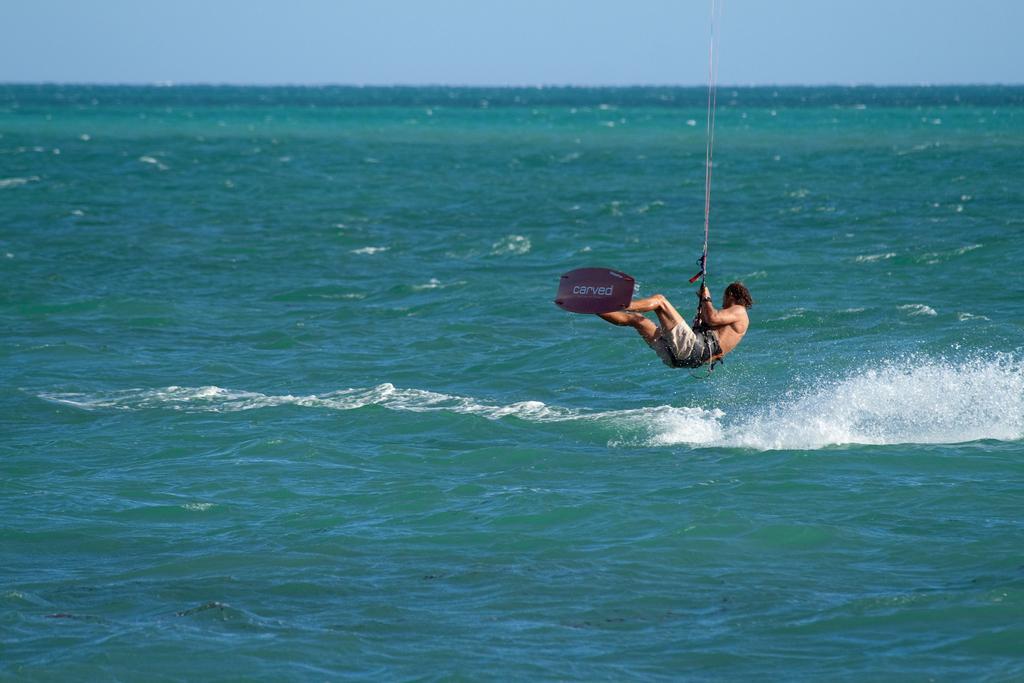Please provide a concise description of this image. In this image we can see a person wearing short doing surfing on the waves and the board is of pink color holding a rope which is tied to his waist and in the background of the image we can see water and clear sky. 